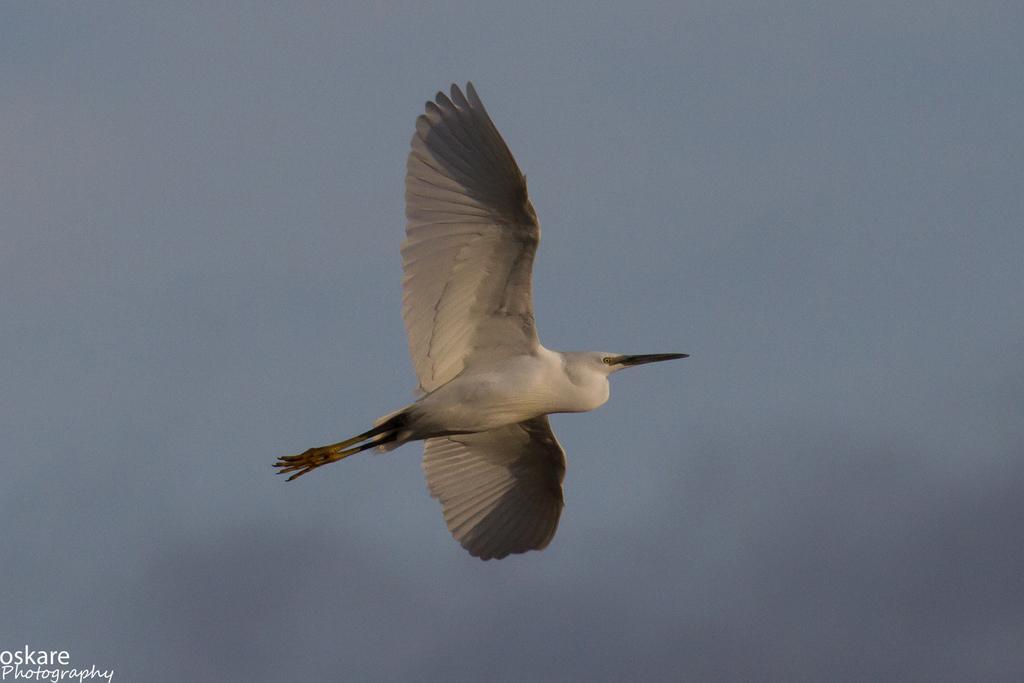Can you describe this image briefly? In the center of the image there is a bird flying in the air. In the background there is a cloudy sky and on the bottom left there is text. 